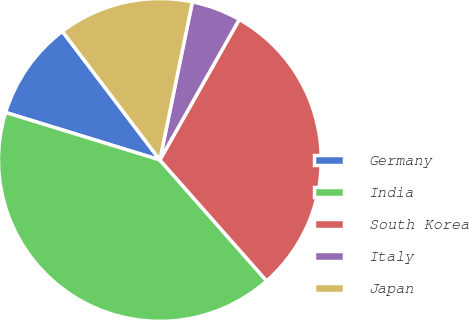Convert chart. <chart><loc_0><loc_0><loc_500><loc_500><pie_chart><fcel>Germany<fcel>India<fcel>South Korea<fcel>Italy<fcel>Japan<nl><fcel>9.92%<fcel>41.26%<fcel>30.3%<fcel>4.96%<fcel>13.55%<nl></chart> 